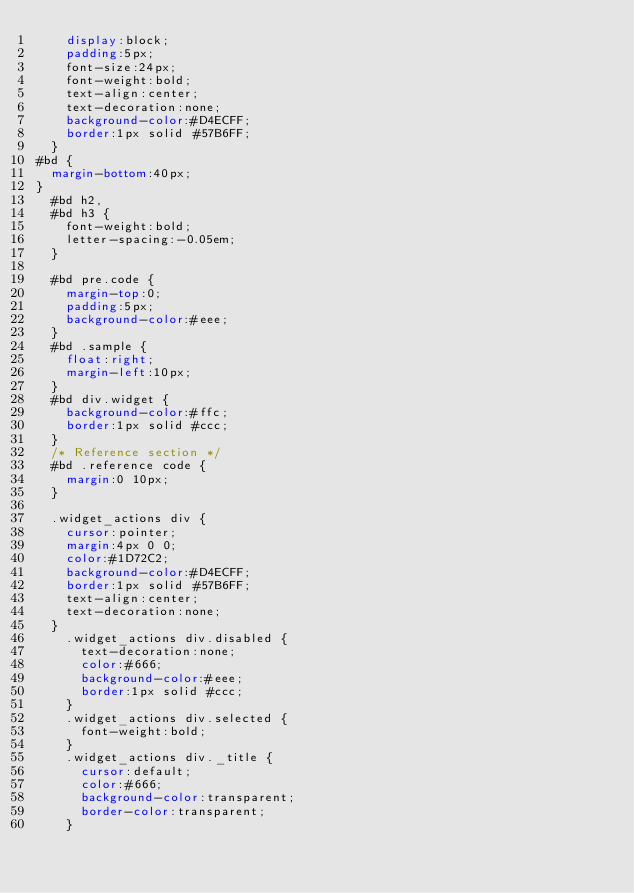Convert code to text. <code><loc_0><loc_0><loc_500><loc_500><_CSS_>    display:block;
    padding:5px;
    font-size:24px;
    font-weight:bold;
    text-align:center;
    text-decoration:none;
    background-color:#D4ECFF;
    border:1px solid #57B6FF;
  }
#bd {
  margin-bottom:40px;
}
  #bd h2,
  #bd h3 {
    font-weight:bold;
    letter-spacing:-0.05em;
  }

  #bd pre.code {
    margin-top:0;
    padding:5px;
    background-color:#eee;
  }
  #bd .sample {
    float:right;
    margin-left:10px;
  }
  #bd div.widget {
    background-color:#ffc;
    border:1px solid #ccc;
  }
  /* Reference section */
  #bd .reference code {
    margin:0 10px;
  }

  .widget_actions div {
    cursor:pointer;
    margin:4px 0 0;
    color:#1D72C2;
    background-color:#D4ECFF;
    border:1px solid #57B6FF;
    text-align:center;
    text-decoration:none;
  }
    .widget_actions div.disabled {
      text-decoration:none;
      color:#666;
      background-color:#eee;
      border:1px solid #ccc;
    }
    .widget_actions div.selected {
      font-weight:bold;
    }
    .widget_actions div._title {
      cursor:default;
      color:#666;
      background-color:transparent;
      border-color:transparent;
    }
</code> 